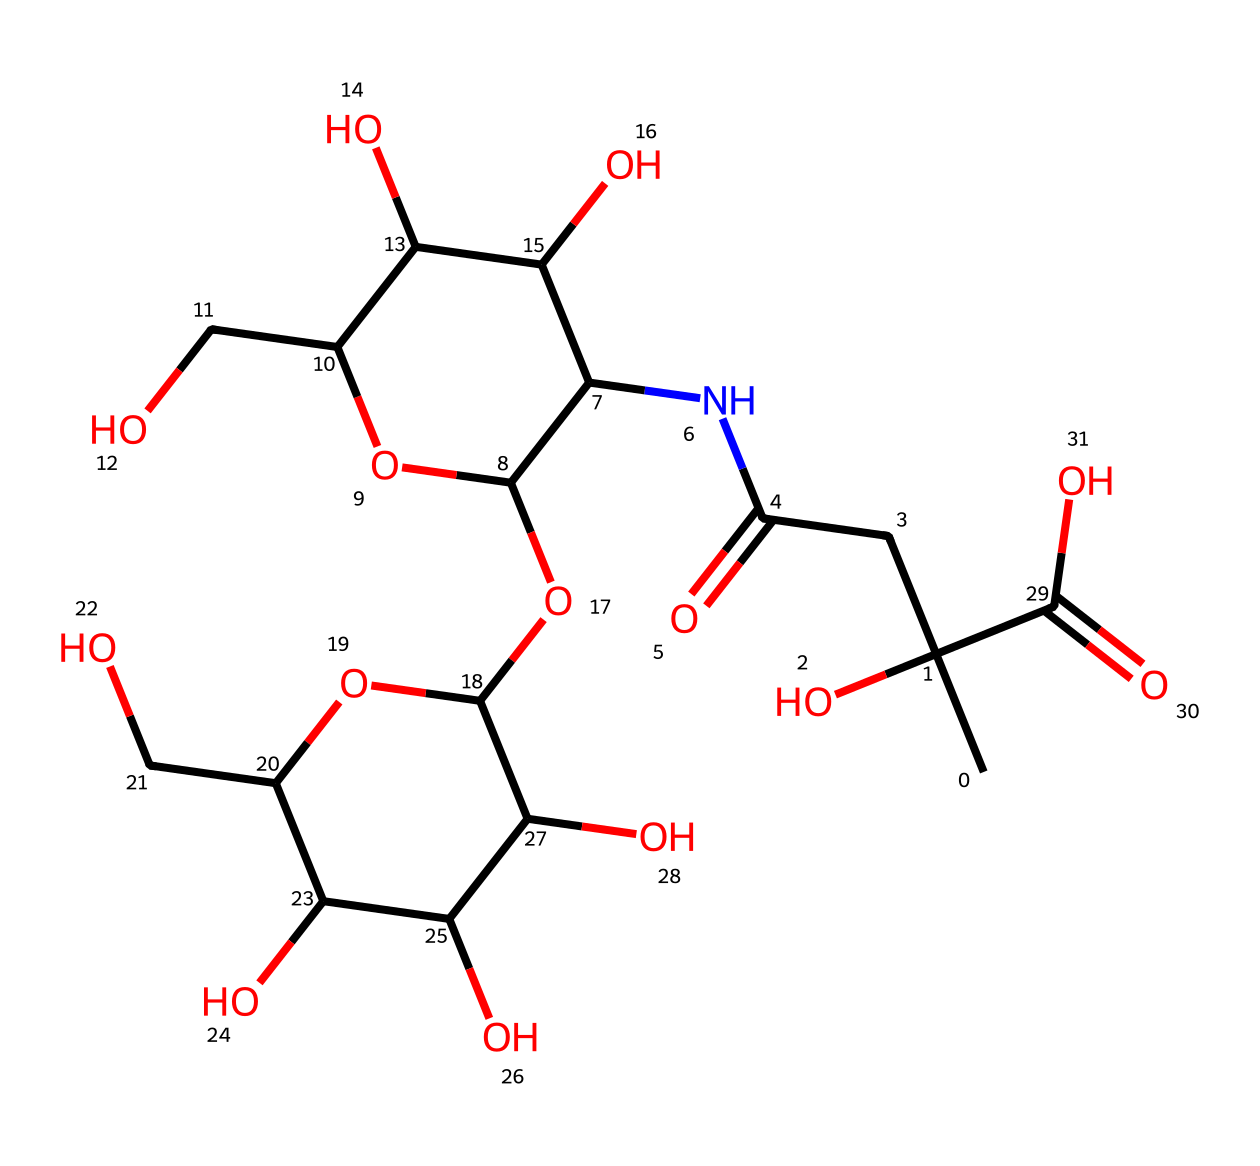What is the primary functional group present in hyaluronic acid? The chemical structure contains multiple hydroxyl groups (-OH), which are indicative of alcohols. The presence of carboxylic acid groups (-COOH) further supports that it is a polyacid.
Answer: hydroxyl How many carbon atoms are in the structure of hyaluronic acid? By examining the SMILES representation, the total count of carbon atoms can be performed. In this case, after careful counting, there are 14 carbon atoms present in the structure.
Answer: 14 What type of chemical is hyaluronic acid classified as? Hyaluronic acid is a polymer of repeating disaccharide units consisting of uronic acid and glucosamine, thus it is classified as a glycosaminoglycan.
Answer: glycosaminoglycan What elements are present in the chemical structure of hyaluronic acid? The SMILES representation reveals the presence of carbon (C), hydrogen (H), oxygen (O), and nitrogen (N) elements. These are counted by identifying their respective atoms in the structure.
Answer: carbon, hydrogen, oxygen, nitrogen What is the average number of hydroxyl groups present in each repeating unit of hyaluronic acid? The analysis of the structure reveals that each disaccharide repeating unit has 4 hydroxyl groups when considering the structure of hyaluronic acid. This indicates its high hydrophilicity and ability to retain moisture.
Answer: 4 